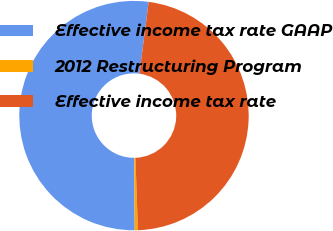<chart> <loc_0><loc_0><loc_500><loc_500><pie_chart><fcel>Effective income tax rate GAAP<fcel>2012 Restructuring Program<fcel>Effective income tax rate<nl><fcel>52.15%<fcel>0.45%<fcel>47.41%<nl></chart> 